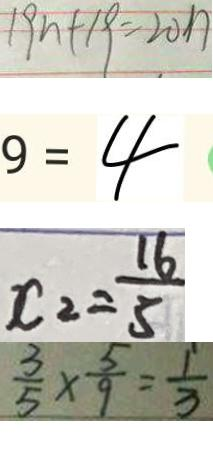<formula> <loc_0><loc_0><loc_500><loc_500>1 9 n + 1 9 = 2 0 n 
 9 = 4 
 x _ { 2 } = \frac { 1 6 } { 5 } 
 \frac { 3 } { 5 } \times \frac { 5 } { 9 } = \frac { 1 } { 3 }</formula> 